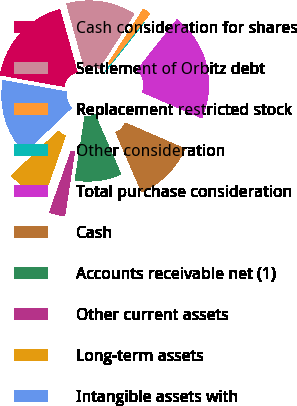<chart> <loc_0><loc_0><loc_500><loc_500><pie_chart><fcel>Cash consideration for shares<fcel>Settlement of Orbitz debt<fcel>Replacement restricted stock<fcel>Other consideration<fcel>Total purchase consideration<fcel>Cash<fcel>Accounts receivable net (1)<fcel>Other current assets<fcel>Long-term assets<fcel>Intangible assets with<nl><fcel>17.9%<fcel>13.43%<fcel>1.51%<fcel>0.02%<fcel>20.88%<fcel>11.94%<fcel>8.96%<fcel>3.0%<fcel>7.47%<fcel>14.92%<nl></chart> 